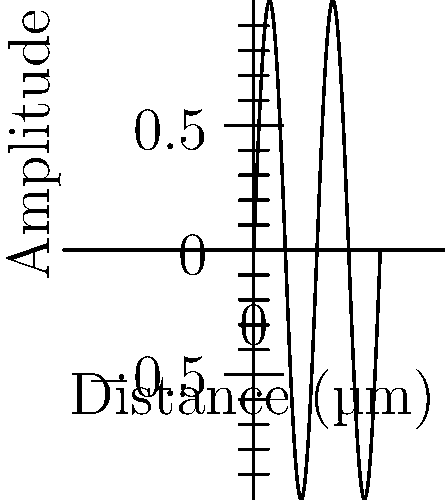In a hospital sterilization unit, UV-C light is used to disinfect equipment. The graph shows a sinusoidal wave representing UV-C light. Given that the wavelength of this UV-C light is 254 nm, which is known to be effective for sterilization, calculate the frequency of this light. How might this information be relevant when designing healthcare policies for equipment sterilization standards? To solve this problem, we'll follow these steps:

1. Recall the relationship between wavelength ($\lambda$), frequency ($f$), and the speed of light ($c$):

   $c = \lambda f$

2. We know:
   - The speed of light, $c = 3 \times 10^8$ m/s
   - The wavelength, $\lambda = 254$ nm $= 254 \times 10^{-9}$ m

3. Substitute these values into the equation:

   $3 \times 10^8 = (254 \times 10^{-9}) f$

4. Solve for $f$:

   $f = \frac{3 \times 10^8}{254 \times 10^{-9}} = 1.18 \times 10^{15}$ Hz

5. Round to three significant figures:

   $f \approx 1.18 \times 10^{15}$ Hz

This frequency is relevant to healthcare policy because:

a) It ensures that the UV-C light used in sterilization equipment is at the correct wavelength and frequency to effectively inactivate microorganisms.

b) Understanding the specific frequency helps in setting standards for UV sterilization equipment in healthcare facilities.

c) This knowledge can inform training programs for healthcare workers on proper use and maintenance of UV sterilization equipment.

d) It can guide the development of safety protocols to protect staff from UV exposure while using sterilization equipment.

e) This information can be used to compare different sterilization methods and their effectiveness in healthcare settings.
Answer: $1.18 \times 10^{15}$ Hz 